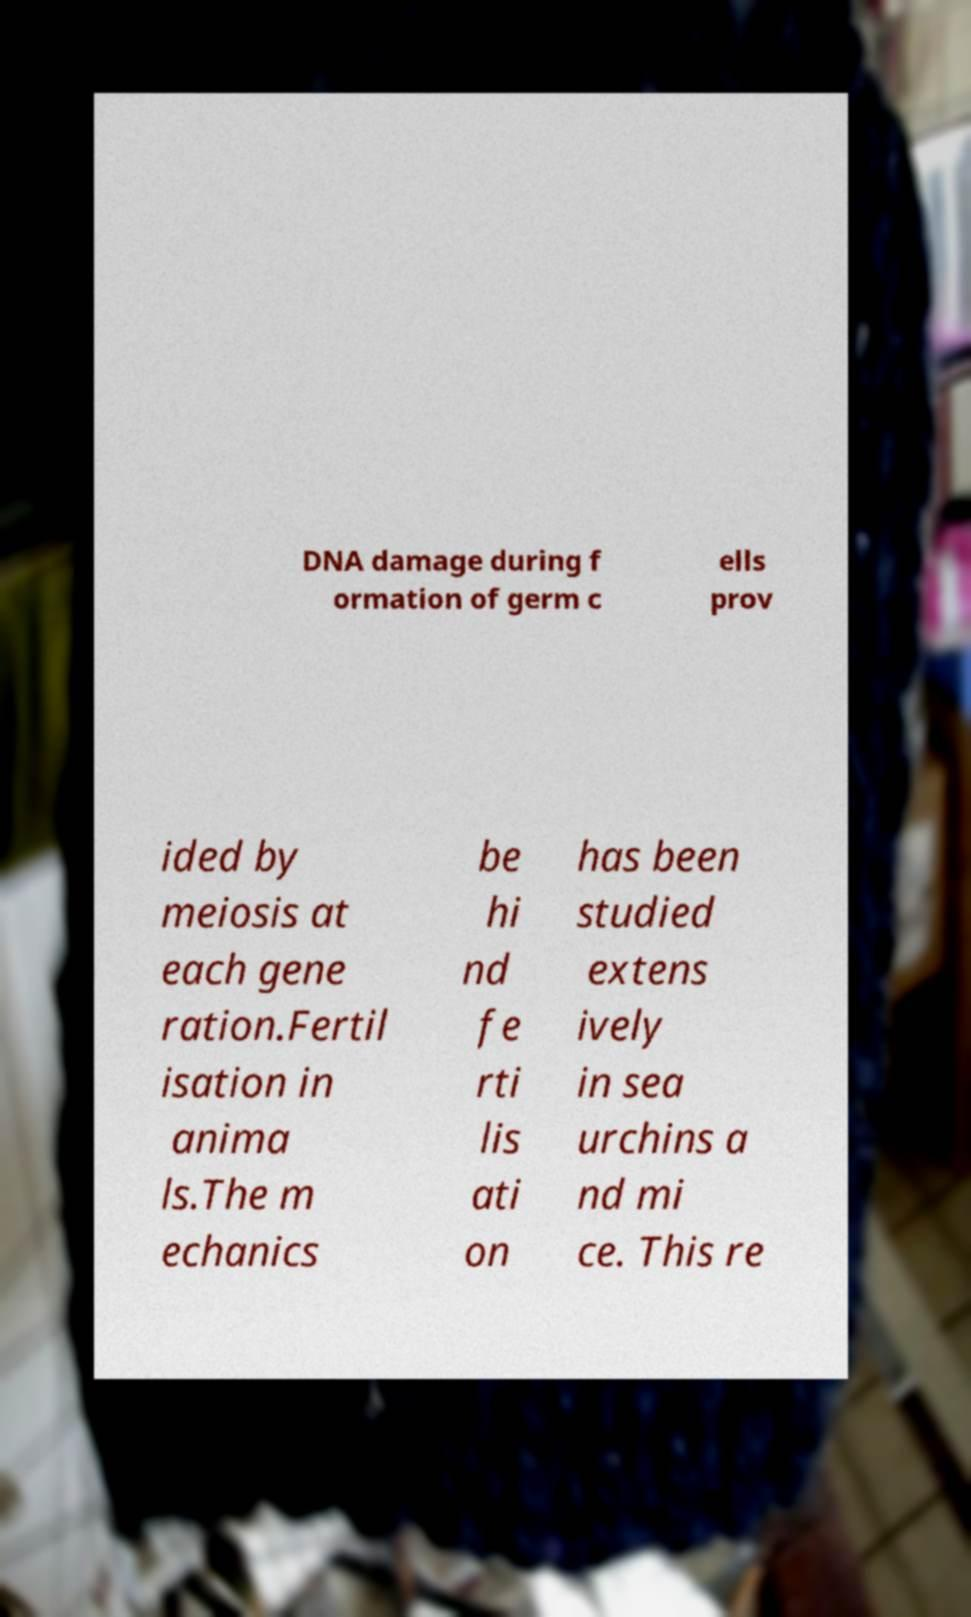I need the written content from this picture converted into text. Can you do that? DNA damage during f ormation of germ c ells prov ided by meiosis at each gene ration.Fertil isation in anima ls.The m echanics be hi nd fe rti lis ati on has been studied extens ively in sea urchins a nd mi ce. This re 